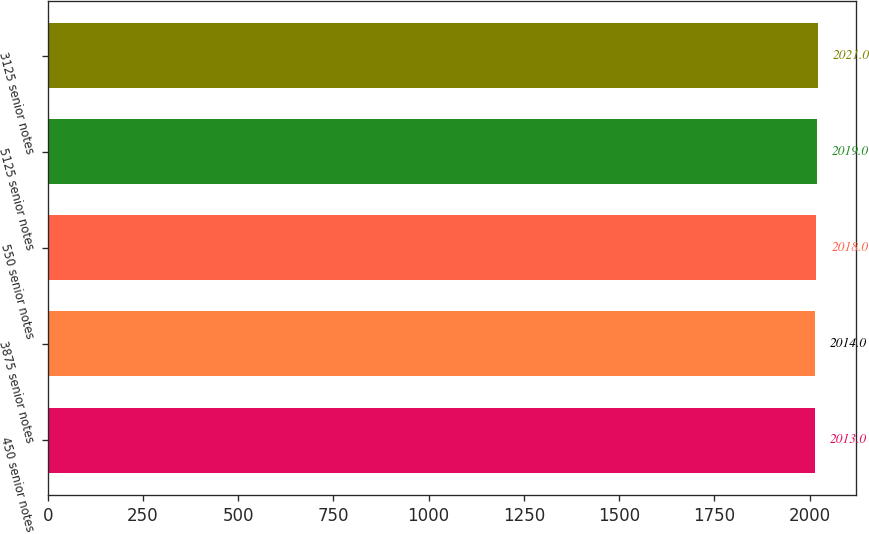Convert chart. <chart><loc_0><loc_0><loc_500><loc_500><bar_chart><fcel>450 senior notes<fcel>3875 senior notes<fcel>550 senior notes<fcel>5125 senior notes<fcel>3125 senior notes<nl><fcel>2013<fcel>2014<fcel>2018<fcel>2019<fcel>2021<nl></chart> 